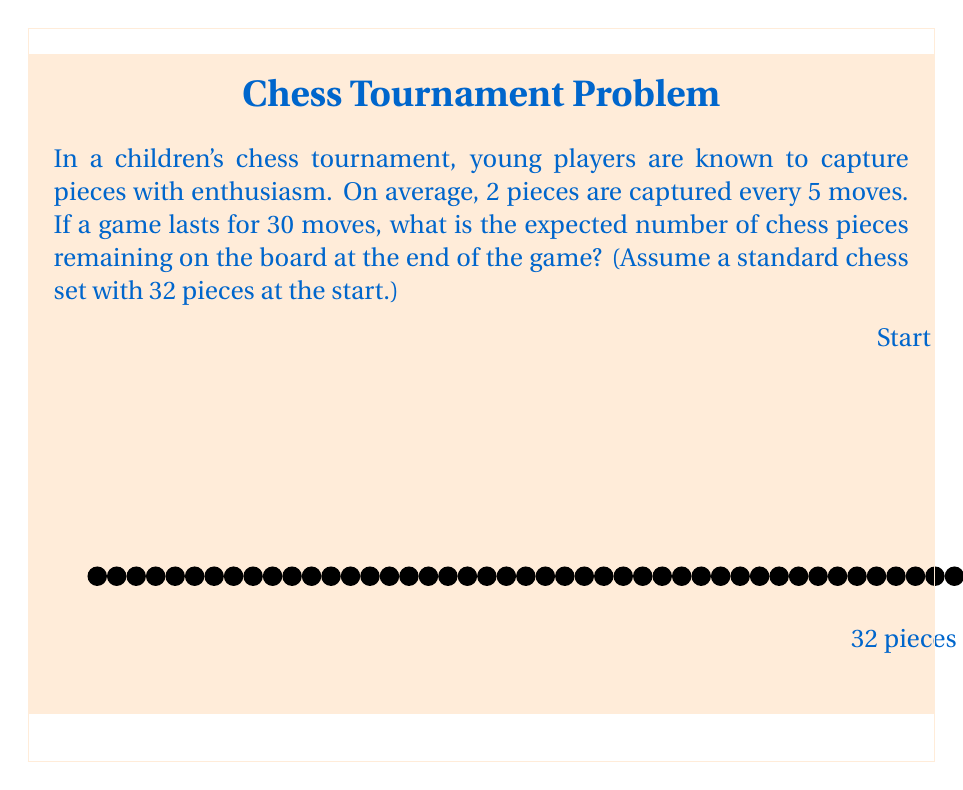Give your solution to this math problem. Let's approach this step-by-step:

1) First, we need to calculate the rate at which pieces are being captured:
   $$\text{Rate} = \frac{2 \text{ pieces}}{5 \text{ moves}}$$

2) Now, we can calculate how many pieces are expected to be captured in 30 moves:
   $$\text{Expected captures} = \frac{2 \text{ pieces}}{5 \text{ moves}} \times 30 \text{ moves}$$
   $$= 2 \times 6 = 12 \text{ pieces}$$

3) We started with 32 pieces, so the expected number of pieces remaining is:
   $$\text{Remaining pieces} = 32 - 12 = 20 \text{ pieces}$$

4) To verify, we can calculate the expected percentage of pieces remaining:
   $$\text{Percentage remaining} = \frac{20}{32} \times 100\% = 62.5\%$$

   This seems reasonable for a typical chess game.

Therefore, the expected number of chess pieces remaining on the board after 30 moves is 20.
Answer: 20 pieces 